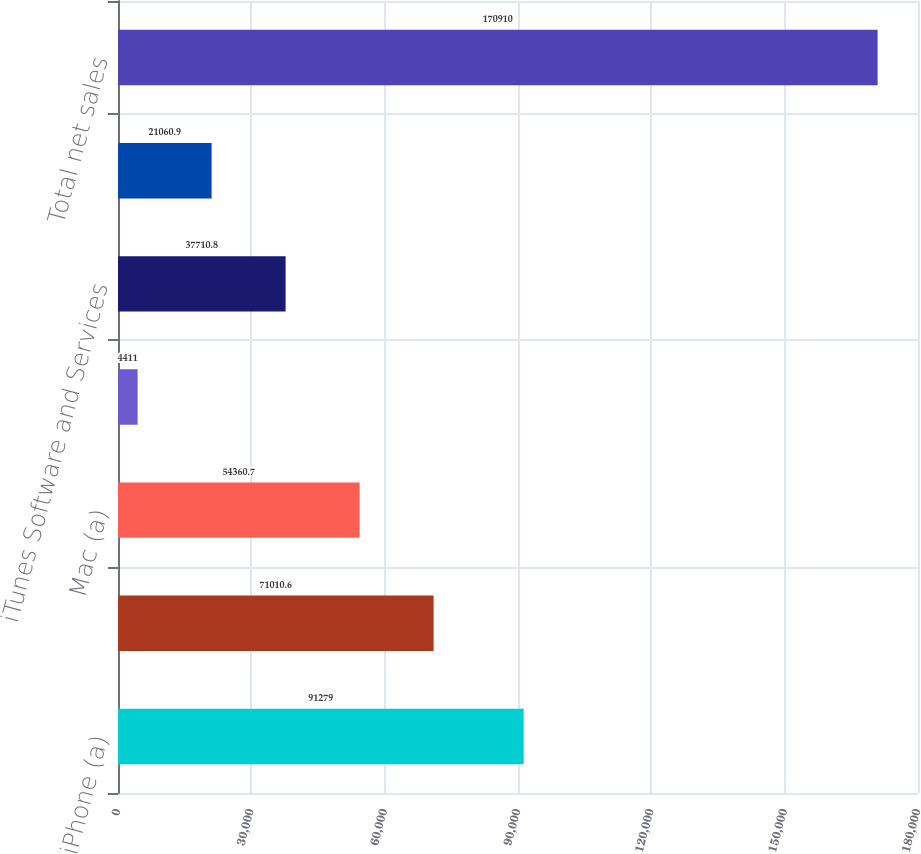Convert chart. <chart><loc_0><loc_0><loc_500><loc_500><bar_chart><fcel>iPhone (a)<fcel>iPad (a)<fcel>Mac (a)<fcel>iPod (a)<fcel>iTunes Software and Services<fcel>Accessories (c)<fcel>Total net sales<nl><fcel>91279<fcel>71010.6<fcel>54360.7<fcel>4411<fcel>37710.8<fcel>21060.9<fcel>170910<nl></chart> 